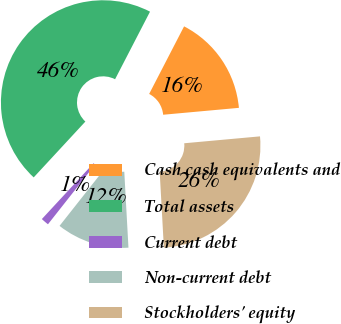<chart> <loc_0><loc_0><loc_500><loc_500><pie_chart><fcel>Cash cash equivalents and<fcel>Total assets<fcel>Current debt<fcel>Non-current debt<fcel>Stockholders' equity<nl><fcel>15.96%<fcel>45.71%<fcel>1.25%<fcel>11.51%<fcel>25.57%<nl></chart> 